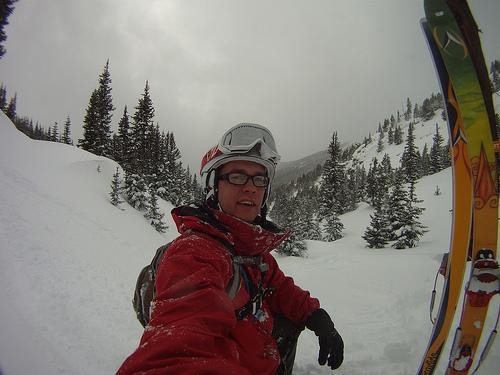Examine the clothing and accessories that the man is wearing and provide a detailed description. The man is wearing a thick red snow jacket with speckles of snow, grey and black straps on his chest, clear spectacles, a pair of black snow gloves, and some straps on the front of his jacket. How many pairs of skis are in the image and what are their colors? There are two pairs of skis, one being multicolored and the other being yellow. Mention the most prominent weather conditions and landscape elements in the image. The image features a thick misty sky, snow-covered ground, mountainside with trees, and a valley covered with trees. What are the primary colors of the man's attire and accessories in the image? The primary colors of the man's attire and accessories are red, black, white, and a bit of grey. Enumerate the different types of trees present in the image. The image includes a small tree and several trees, both covered with snow, and a pine tree also covered in snow. Provide a brief description of the image focusing on the man and his attire. A man wearing a red coat, helmet, glasses, and black gloves is skiing on a mountain, surrounded by snow-covered trees and carrying skis. What items are the man holding or carrying in this image? The man is holding a pair of multicolored skis, and a brown backpack on his back. What are some notable landscape features in the image besides the presence of snow? Notable landscape features include a mountain side covered in snow, dark clouds in the sky, a hillside covered with snow, tracks in the snow, and several trees covered in snow. Describe the facial features and headwear of the man in the scene. The man has an open mouth and black glasses on his face, white ski goggles on his helmet, and a white and red helmet on his head. Describe the overall atmosphere of the image based on the colors, elements, and visuals. The atmosphere is filled with excitement and adventure as the man dressed in colorful clothes skis through a snow-covered landscape with picturesque trees, mountains, and thick misty skies. 